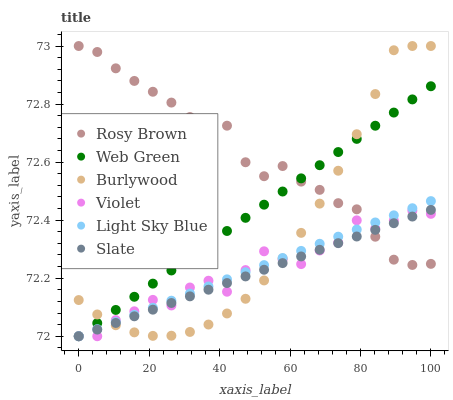Does Slate have the minimum area under the curve?
Answer yes or no. Yes. Does Rosy Brown have the maximum area under the curve?
Answer yes or no. Yes. Does Rosy Brown have the minimum area under the curve?
Answer yes or no. No. Does Slate have the maximum area under the curve?
Answer yes or no. No. Is Light Sky Blue the smoothest?
Answer yes or no. Yes. Is Violet the roughest?
Answer yes or no. Yes. Is Slate the smoothest?
Answer yes or no. No. Is Slate the roughest?
Answer yes or no. No. Does Slate have the lowest value?
Answer yes or no. Yes. Does Rosy Brown have the lowest value?
Answer yes or no. No. Does Rosy Brown have the highest value?
Answer yes or no. Yes. Does Slate have the highest value?
Answer yes or no. No. Does Light Sky Blue intersect Rosy Brown?
Answer yes or no. Yes. Is Light Sky Blue less than Rosy Brown?
Answer yes or no. No. Is Light Sky Blue greater than Rosy Brown?
Answer yes or no. No. 